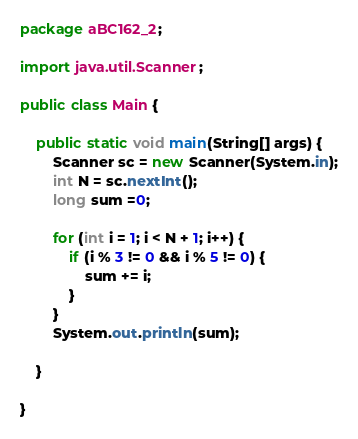Convert code to text. <code><loc_0><loc_0><loc_500><loc_500><_Java_>package aBC162_2;

import java.util.Scanner;

public class Main {

	public static void main(String[] args) {
		Scanner sc = new Scanner(System.in);
		int N = sc.nextInt();
		long sum =0;

		for (int i = 1; i < N + 1; i++) {
			if (i % 3 != 0 && i % 5 != 0) {
				sum += i;
			}
		}
		System.out.println(sum);

	}

}
</code> 